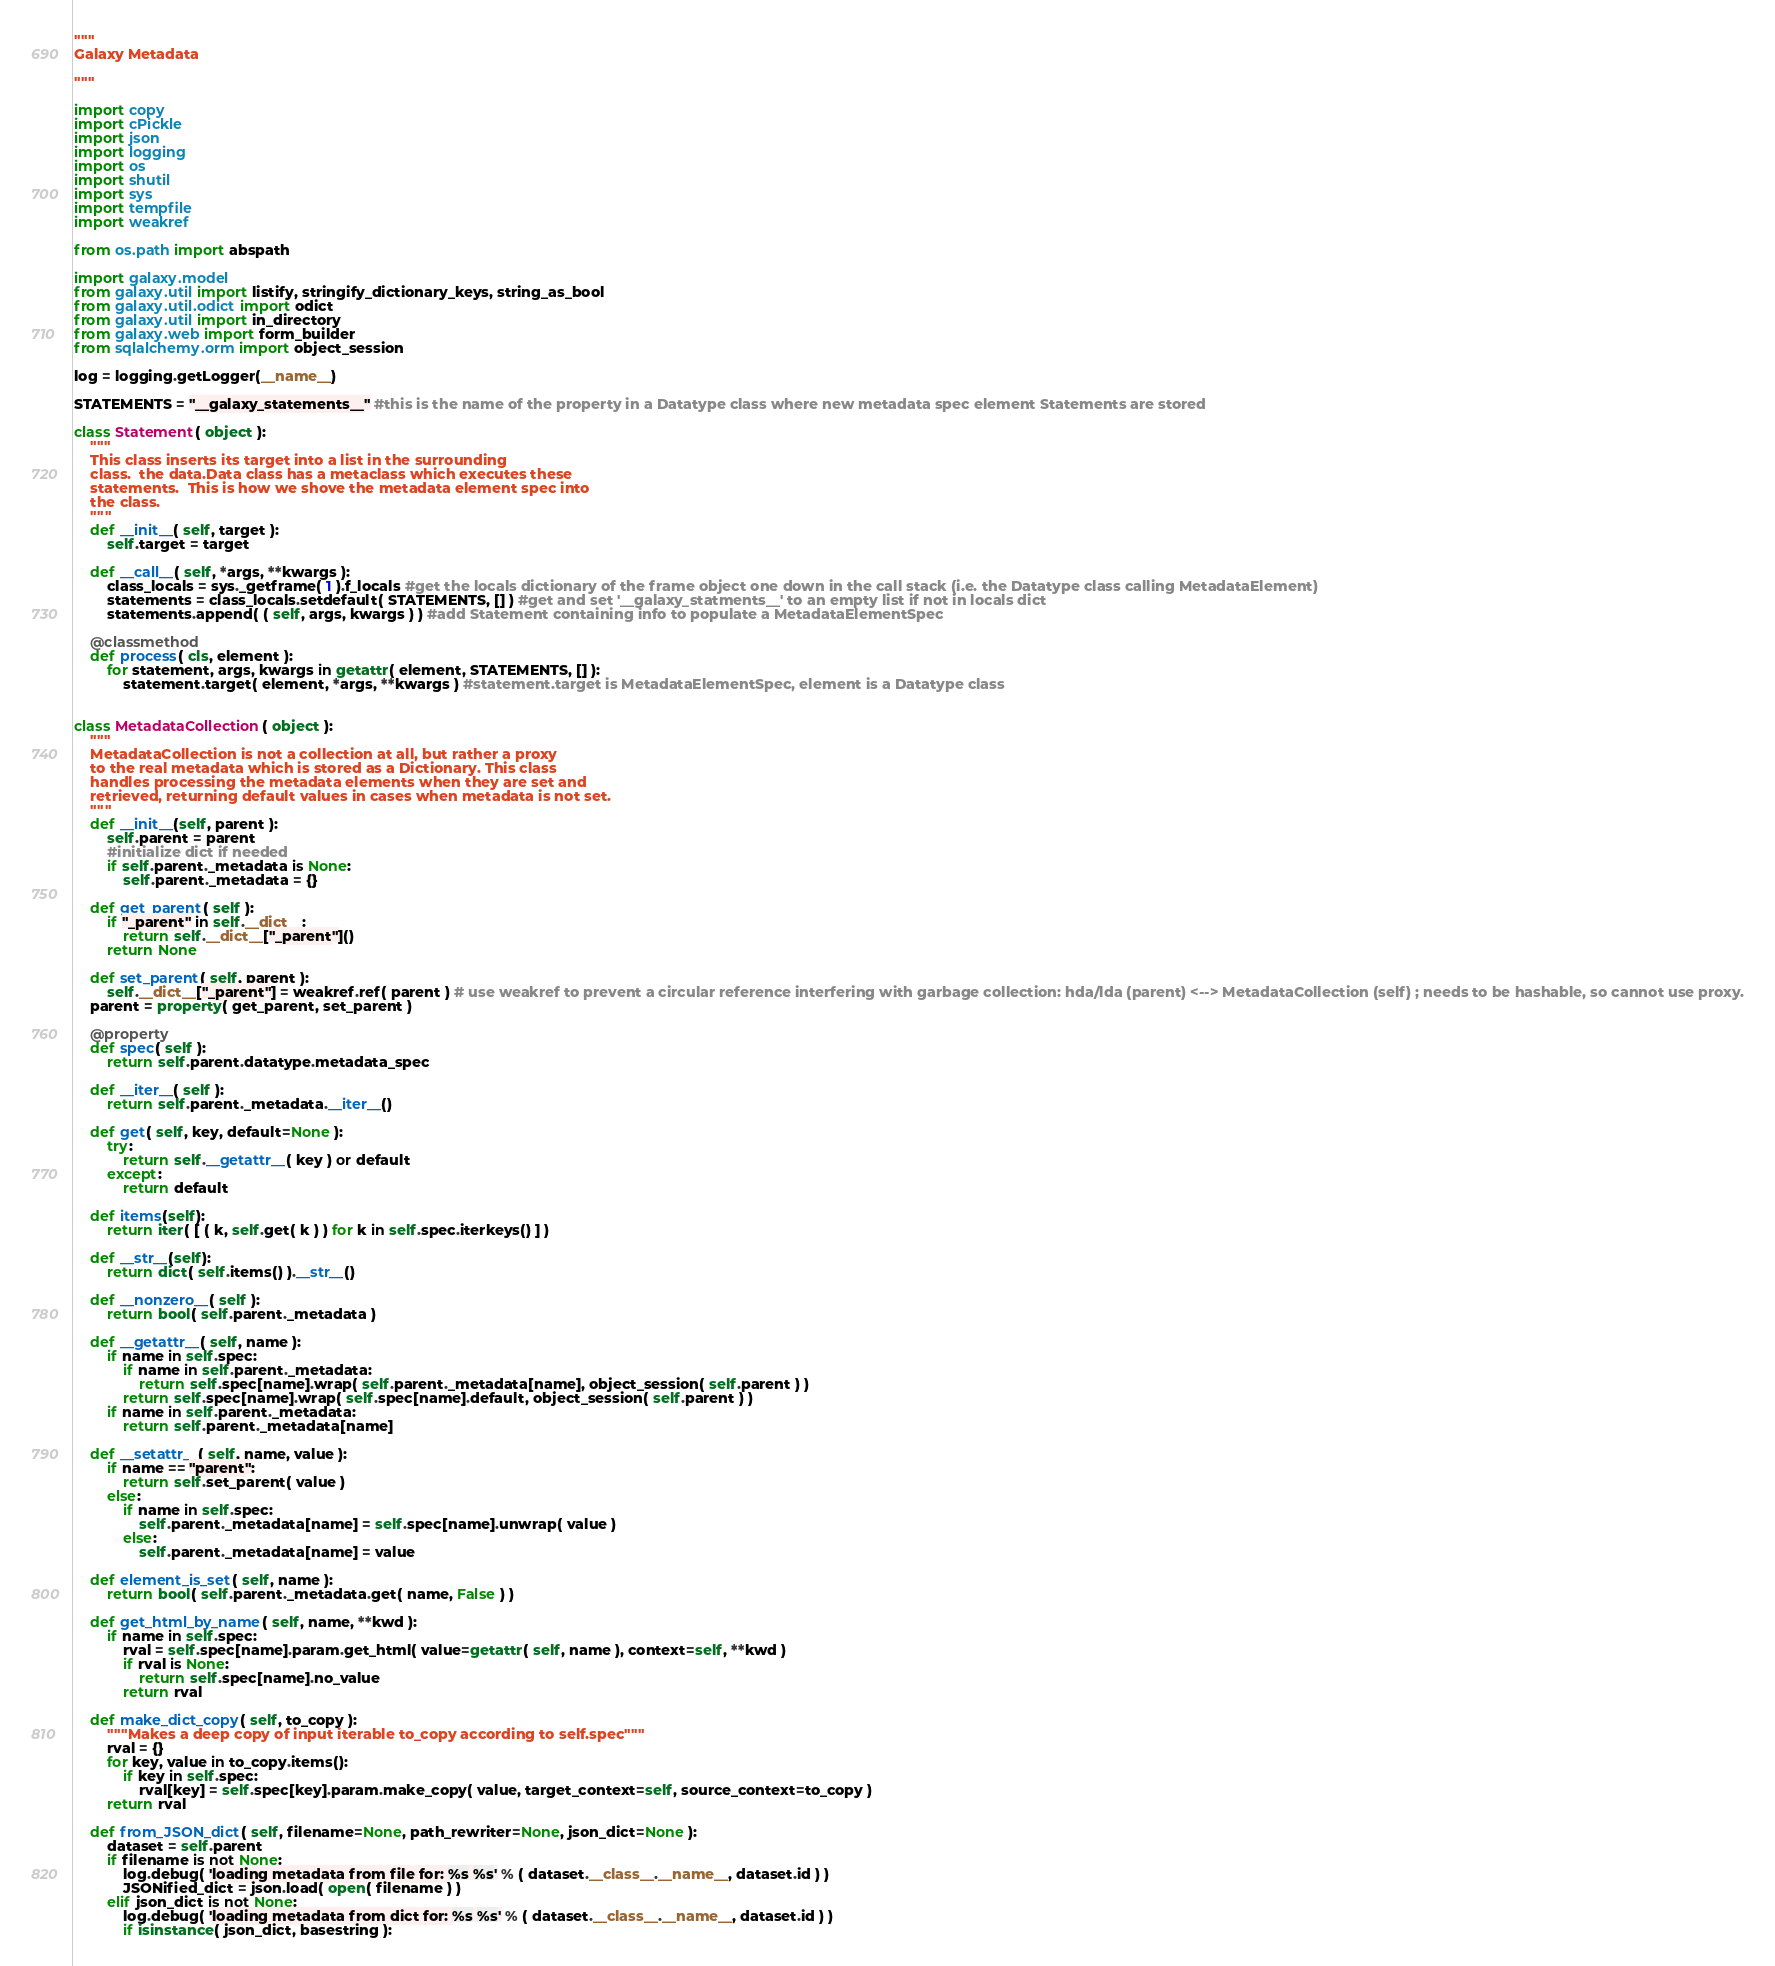<code> <loc_0><loc_0><loc_500><loc_500><_Python_>"""
Galaxy Metadata

"""

import copy
import cPickle
import json
import logging
import os
import shutil
import sys
import tempfile
import weakref

from os.path import abspath

import galaxy.model
from galaxy.util import listify, stringify_dictionary_keys, string_as_bool
from galaxy.util.odict import odict
from galaxy.util import in_directory
from galaxy.web import form_builder
from sqlalchemy.orm import object_session

log = logging.getLogger(__name__)

STATEMENTS = "__galaxy_statements__" #this is the name of the property in a Datatype class where new metadata spec element Statements are stored

class Statement( object ):
    """
    This class inserts its target into a list in the surrounding
    class.  the data.Data class has a metaclass which executes these
    statements.  This is how we shove the metadata element spec into
    the class.
    """
    def __init__( self, target ):
        self.target = target

    def __call__( self, *args, **kwargs ):
        class_locals = sys._getframe( 1 ).f_locals #get the locals dictionary of the frame object one down in the call stack (i.e. the Datatype class calling MetadataElement)
        statements = class_locals.setdefault( STATEMENTS, [] ) #get and set '__galaxy_statments__' to an empty list if not in locals dict
        statements.append( ( self, args, kwargs ) ) #add Statement containing info to populate a MetadataElementSpec

    @classmethod
    def process( cls, element ):
        for statement, args, kwargs in getattr( element, STATEMENTS, [] ):
            statement.target( element, *args, **kwargs ) #statement.target is MetadataElementSpec, element is a Datatype class


class MetadataCollection( object ):
    """
    MetadataCollection is not a collection at all, but rather a proxy
    to the real metadata which is stored as a Dictionary. This class
    handles processing the metadata elements when they are set and
    retrieved, returning default values in cases when metadata is not set.
    """
    def __init__(self, parent ):
        self.parent = parent
        #initialize dict if needed
        if self.parent._metadata is None:
            self.parent._metadata = {}

    def get_parent( self ):
        if "_parent" in self.__dict__:
            return self.__dict__["_parent"]()
        return None

    def set_parent( self, parent ):
        self.__dict__["_parent"] = weakref.ref( parent ) # use weakref to prevent a circular reference interfering with garbage collection: hda/lda (parent) <--> MetadataCollection (self) ; needs to be hashable, so cannot use proxy.
    parent = property( get_parent, set_parent )

    @property
    def spec( self ):
        return self.parent.datatype.metadata_spec

    def __iter__( self ):
        return self.parent._metadata.__iter__()

    def get( self, key, default=None ):
        try:
            return self.__getattr__( key ) or default
        except:
            return default

    def items(self):
        return iter( [ ( k, self.get( k ) ) for k in self.spec.iterkeys() ] )

    def __str__(self):
        return dict( self.items() ).__str__()

    def __nonzero__( self ):
        return bool( self.parent._metadata )

    def __getattr__( self, name ):
        if name in self.spec:
            if name in self.parent._metadata:
                return self.spec[name].wrap( self.parent._metadata[name], object_session( self.parent ) )
            return self.spec[name].wrap( self.spec[name].default, object_session( self.parent ) )
        if name in self.parent._metadata:
            return self.parent._metadata[name]

    def __setattr__( self, name, value ):
        if name == "parent":
            return self.set_parent( value )
        else:
            if name in self.spec:
                self.parent._metadata[name] = self.spec[name].unwrap( value )
            else:
                self.parent._metadata[name] = value

    def element_is_set( self, name ):
        return bool( self.parent._metadata.get( name, False ) )

    def get_html_by_name( self, name, **kwd ):
        if name in self.spec:
            rval = self.spec[name].param.get_html( value=getattr( self, name ), context=self, **kwd )
            if rval is None:
                return self.spec[name].no_value
            return rval

    def make_dict_copy( self, to_copy ):
        """Makes a deep copy of input iterable to_copy according to self.spec"""
        rval = {}
        for key, value in to_copy.items():
            if key in self.spec:
                rval[key] = self.spec[key].param.make_copy( value, target_context=self, source_context=to_copy )
        return rval

    def from_JSON_dict( self, filename=None, path_rewriter=None, json_dict=None ):
        dataset = self.parent
        if filename is not None:
            log.debug( 'loading metadata from file for: %s %s' % ( dataset.__class__.__name__, dataset.id ) )
            JSONified_dict = json.load( open( filename ) )
        elif json_dict is not None:
            log.debug( 'loading metadata from dict for: %s %s' % ( dataset.__class__.__name__, dataset.id ) )
            if isinstance( json_dict, basestring ):</code> 